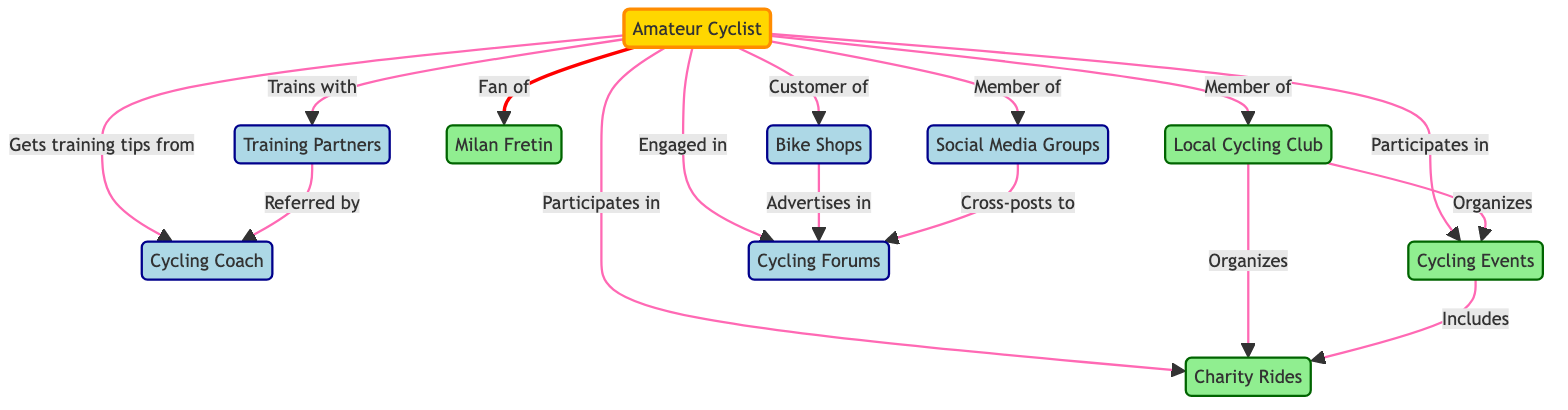What is the total number of nodes in the diagram? The diagram shows a total of 10 nodes which represent different elements in the cycling community, including the amateur cyclist, local cycling club, and various resources related to cycling.
Answer: 10 What is the relationship between the Amateur Cyclist and Milan Fretin? The diagram indicates that the Amateur Cyclist is a fan of Milan Fretin, as represented by the labeled edge connecting these two nodes.
Answer: Fan of Which node is organized by the Local Cycling Club? The diagram reveals that the Local Cycling Club organizes both Cycling Events and Charity Rides, as shown by the edges connecting these nodes.
Answer: Cycling Events, Charity Rides How many nodes are connected to the Amateur Cyclist? By counting the edges that originate from the Amateur Cyclist in the diagram, we find that there are 8 direct connections to other nodes, illustrating various aspects of their interactions within the cycling community.
Answer: 8 What does the Training Partners node refer to in relation to the Cycling Coach? The diagram shows that the Training Partners are referred by the Cycling Coach, meaning that the coach connects the amateur cyclist to their training partners.
Answer: Referred by Which entities are connected by the edge labeled "Participates in"? The edge labeled "Participates in" connects the Amateur Cyclist to both Cycling Events and Charity Rides, indicating the involvement of the cyclist in these activities.
Answer: Cycling Events, Charity Rides What type of information is exchanged between Bike Shops and Cycling Forums? The edge labeled "Advertises in" indicates that Bike Shops are connected to Cycling Forums, implying that they exchange promotional information and advertisements within that space.
Answer: Advertises in Which node has the most connections in the diagram, indicating a central role? The Amateur Cyclist has the most connections in the diagram, with 8 direct links to other nodes, signifying its central role in the cycling community.
Answer: Amateur Cyclist 